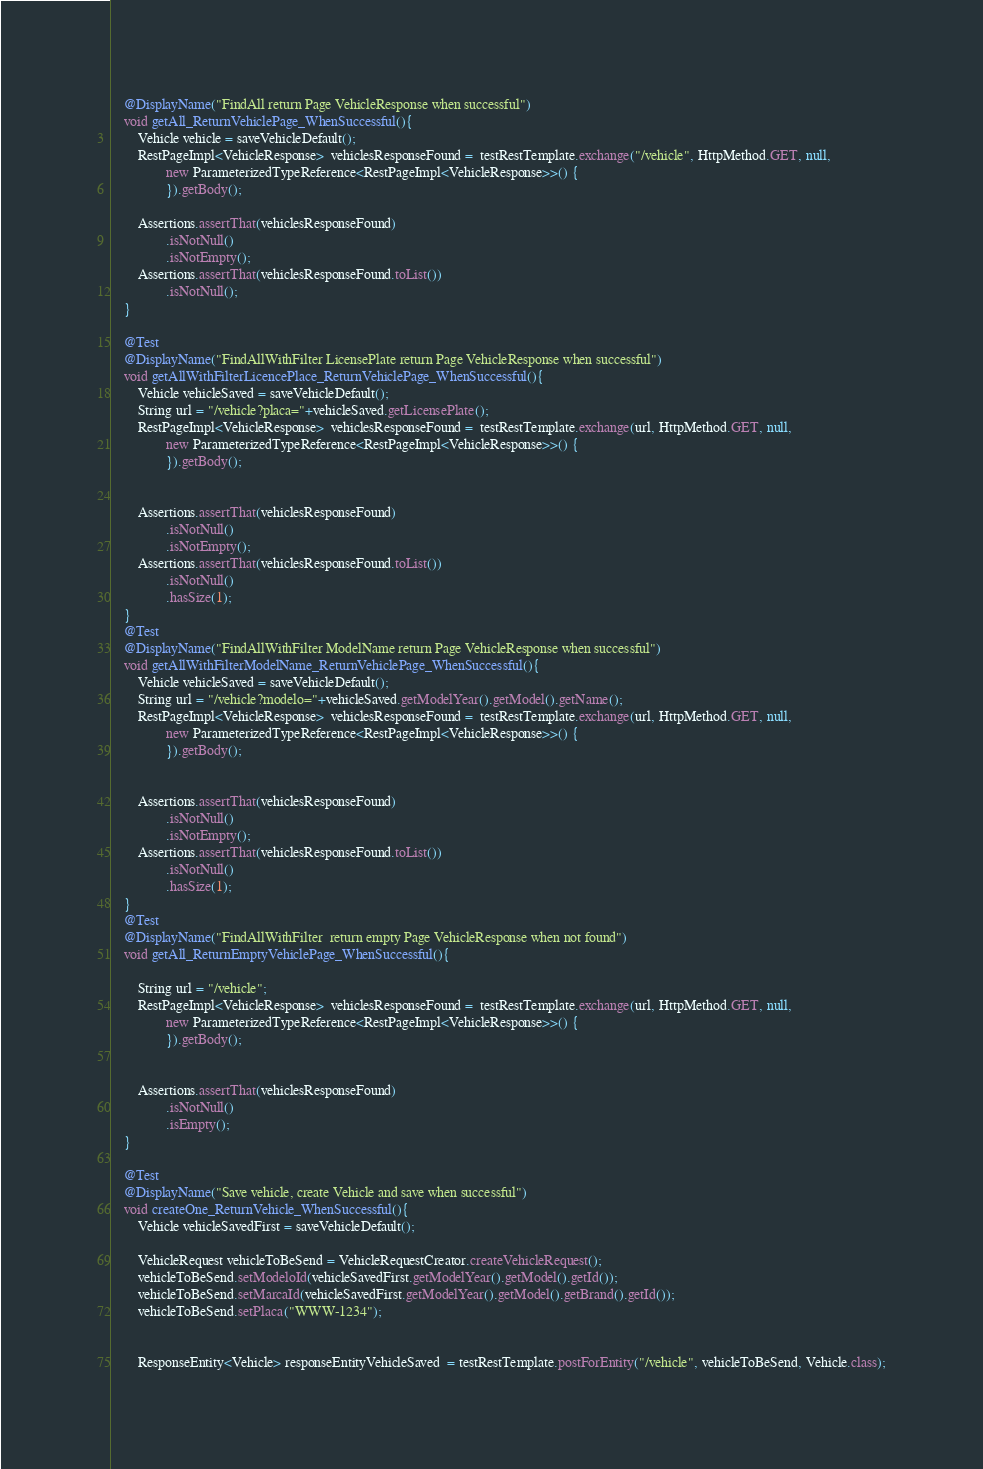<code> <loc_0><loc_0><loc_500><loc_500><_Java_>    @DisplayName("FindAll return Page VehicleResponse when successful")
    void getAll_ReturnVehiclePage_WhenSuccessful(){
        Vehicle vehicle = saveVehicleDefault();
        RestPageImpl<VehicleResponse>  vehiclesResponseFound =  testRestTemplate.exchange("/vehicle", HttpMethod.GET, null,
                new ParameterizedTypeReference<RestPageImpl<VehicleResponse>>() {
                }).getBody();

        Assertions.assertThat(vehiclesResponseFound)
                .isNotNull()
                .isNotEmpty();
        Assertions.assertThat(vehiclesResponseFound.toList())
                .isNotNull();
    }

    @Test
    @DisplayName("FindAllWithFilter LicensePlate return Page VehicleResponse when successful")
    void getAllWithFilterLicencePlace_ReturnVehiclePage_WhenSuccessful(){
        Vehicle vehicleSaved = saveVehicleDefault();
        String url = "/vehicle?placa="+vehicleSaved.getLicensePlate();
        RestPageImpl<VehicleResponse>  vehiclesResponseFound =  testRestTemplate.exchange(url, HttpMethod.GET, null,
                new ParameterizedTypeReference<RestPageImpl<VehicleResponse>>() {
                }).getBody();


        Assertions.assertThat(vehiclesResponseFound)
                .isNotNull()
                .isNotEmpty();
        Assertions.assertThat(vehiclesResponseFound.toList())
                .isNotNull()
                .hasSize(1);
    }
    @Test
    @DisplayName("FindAllWithFilter ModelName return Page VehicleResponse when successful")
    void getAllWithFilterModelName_ReturnVehiclePage_WhenSuccessful(){
        Vehicle vehicleSaved = saveVehicleDefault();
        String url = "/vehicle?modelo="+vehicleSaved.getModelYear().getModel().getName();
        RestPageImpl<VehicleResponse>  vehiclesResponseFound =  testRestTemplate.exchange(url, HttpMethod.GET, null,
                new ParameterizedTypeReference<RestPageImpl<VehicleResponse>>() {
                }).getBody();


        Assertions.assertThat(vehiclesResponseFound)
                .isNotNull()
                .isNotEmpty();
        Assertions.assertThat(vehiclesResponseFound.toList())
                .isNotNull()
                .hasSize(1);
    }
    @Test
    @DisplayName("FindAllWithFilter  return empty Page VehicleResponse when not found")
    void getAll_ReturnEmptyVehiclePage_WhenSuccessful(){

        String url = "/vehicle";
        RestPageImpl<VehicleResponse>  vehiclesResponseFound =  testRestTemplate.exchange(url, HttpMethod.GET, null,
                new ParameterizedTypeReference<RestPageImpl<VehicleResponse>>() {
                }).getBody();


        Assertions.assertThat(vehiclesResponseFound)
                .isNotNull()
                .isEmpty();
    }

    @Test
    @DisplayName("Save vehicle, create Vehicle and save when successful")
    void createOne_ReturnVehicle_WhenSuccessful(){
        Vehicle vehicleSavedFirst = saveVehicleDefault();

        VehicleRequest vehicleToBeSend = VehicleRequestCreator.createVehicleRequest();
        vehicleToBeSend.setModeloId(vehicleSavedFirst.getModelYear().getModel().getId());
        vehicleToBeSend.setMarcaId(vehicleSavedFirst.getModelYear().getModel().getBrand().getId());
        vehicleToBeSend.setPlaca("WWW-1234");


        ResponseEntity<Vehicle> responseEntityVehicleSaved  = testRestTemplate.postForEntity("/vehicle", vehicleToBeSend, Vehicle.class);

</code> 